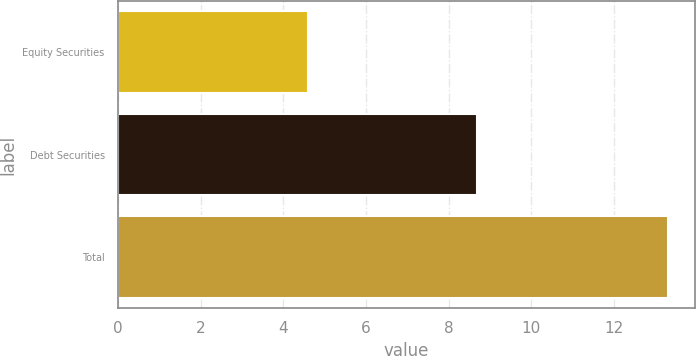Convert chart to OTSL. <chart><loc_0><loc_0><loc_500><loc_500><bar_chart><fcel>Equity Securities<fcel>Debt Securities<fcel>Total<nl><fcel>4.6<fcel>8.7<fcel>13.3<nl></chart> 